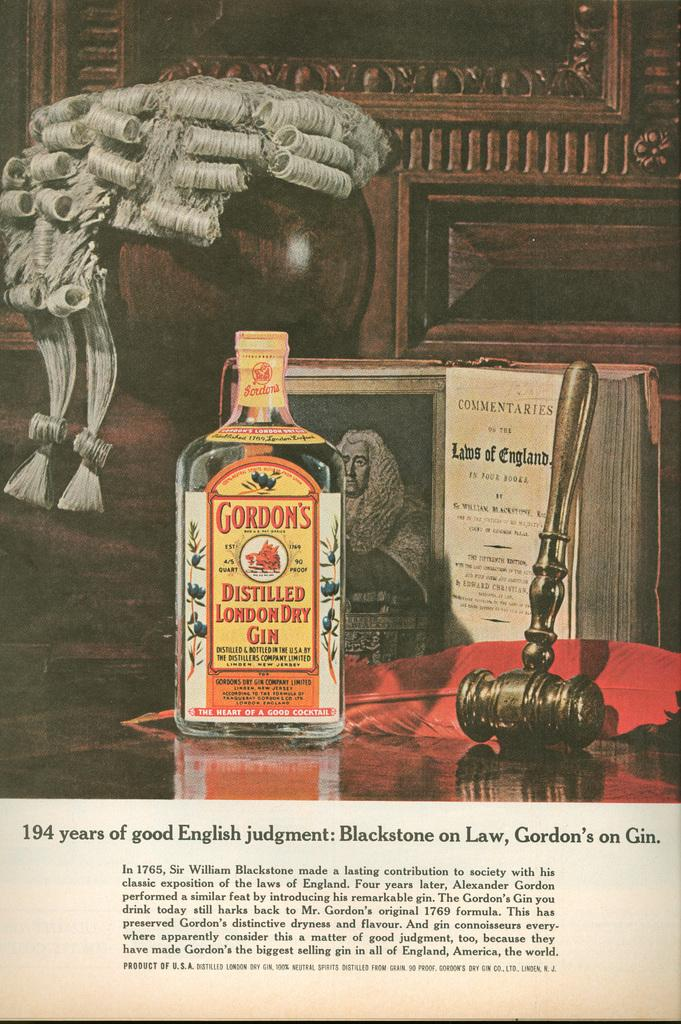<image>
Present a compact description of the photo's key features. Bottle of Gordon's distilled london dry gin beside a commentaries book. 